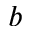<formula> <loc_0><loc_0><loc_500><loc_500>b</formula> 